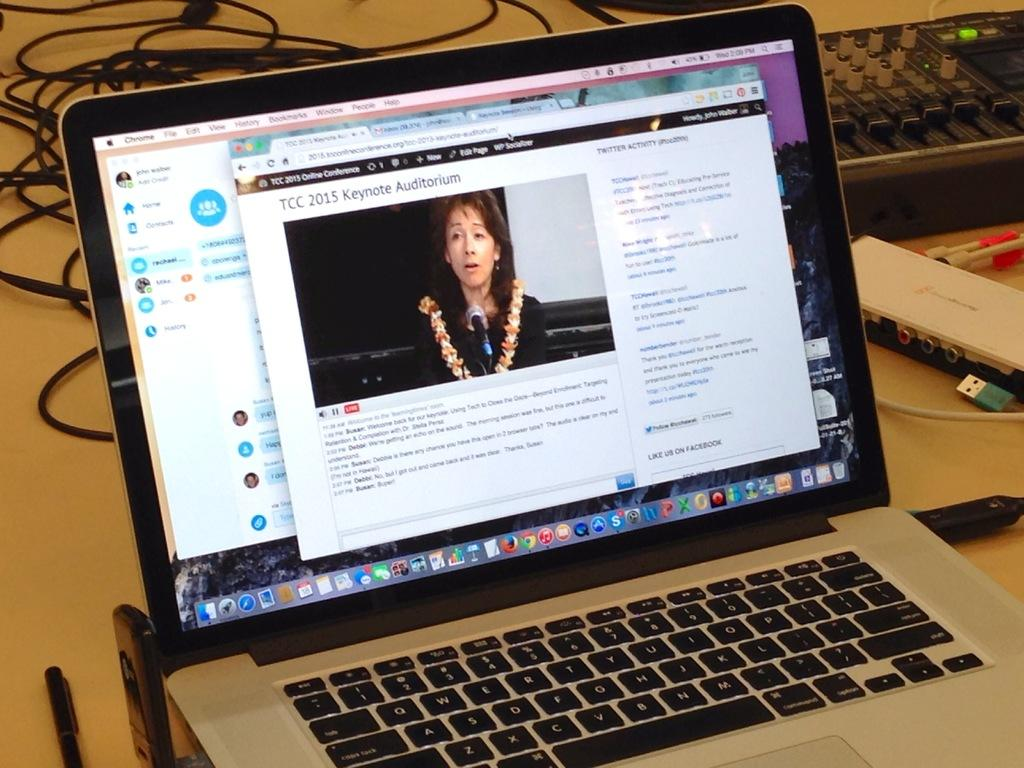<image>
Summarize the visual content of the image. A laptop with an article brought  up on the screen about TCC 2015 Keynote. 